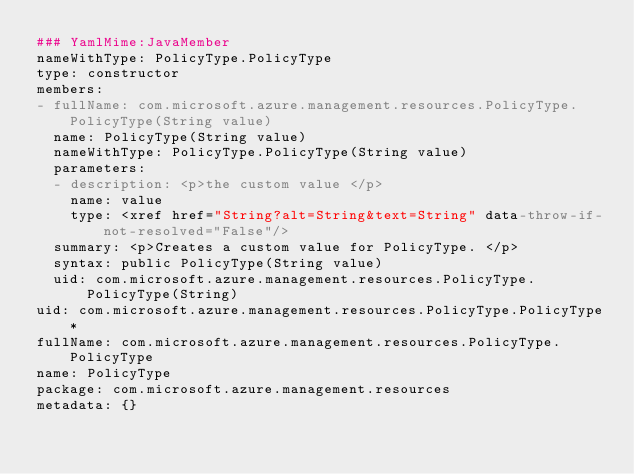Convert code to text. <code><loc_0><loc_0><loc_500><loc_500><_YAML_>### YamlMime:JavaMember
nameWithType: PolicyType.PolicyType
type: constructor
members:
- fullName: com.microsoft.azure.management.resources.PolicyType.PolicyType(String value)
  name: PolicyType(String value)
  nameWithType: PolicyType.PolicyType(String value)
  parameters:
  - description: <p>the custom value </p>
    name: value
    type: <xref href="String?alt=String&text=String" data-throw-if-not-resolved="False"/>
  summary: <p>Creates a custom value for PolicyType. </p>
  syntax: public PolicyType(String value)
  uid: com.microsoft.azure.management.resources.PolicyType.PolicyType(String)
uid: com.microsoft.azure.management.resources.PolicyType.PolicyType*
fullName: com.microsoft.azure.management.resources.PolicyType.PolicyType
name: PolicyType
package: com.microsoft.azure.management.resources
metadata: {}
</code> 